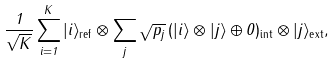<formula> <loc_0><loc_0><loc_500><loc_500>\frac { 1 } { \sqrt { K } } \sum _ { i = 1 } ^ { K } | i \rangle _ { \text {ref} } \otimes \sum _ { j } \sqrt { p _ { j } } \, ( | i \rangle \otimes | j \rangle \oplus 0 ) _ { \text {int} } \otimes | j \rangle _ { \text {ext} } ,</formula> 